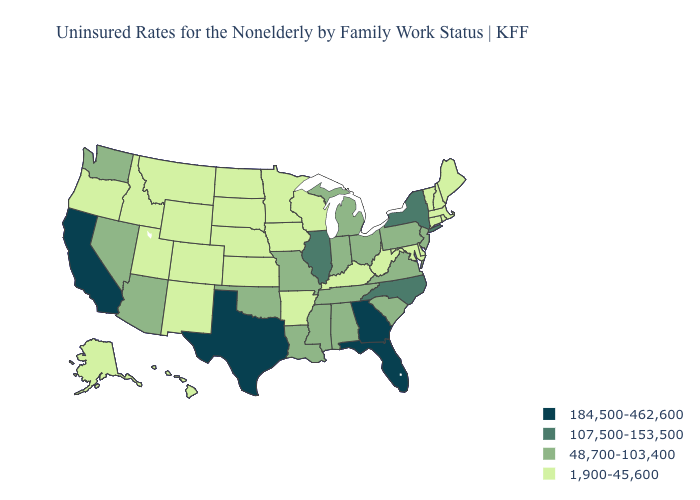Which states hav the highest value in the South?
Short answer required. Florida, Georgia, Texas. What is the value of Connecticut?
Write a very short answer. 1,900-45,600. Does Nevada have the lowest value in the USA?
Be succinct. No. Name the states that have a value in the range 48,700-103,400?
Keep it brief. Alabama, Arizona, Indiana, Louisiana, Michigan, Mississippi, Missouri, Nevada, New Jersey, Ohio, Oklahoma, Pennsylvania, South Carolina, Tennessee, Virginia, Washington. Name the states that have a value in the range 1,900-45,600?
Write a very short answer. Alaska, Arkansas, Colorado, Connecticut, Delaware, Hawaii, Idaho, Iowa, Kansas, Kentucky, Maine, Maryland, Massachusetts, Minnesota, Montana, Nebraska, New Hampshire, New Mexico, North Dakota, Oregon, Rhode Island, South Dakota, Utah, Vermont, West Virginia, Wisconsin, Wyoming. Does New York have a higher value than Arkansas?
Short answer required. Yes. Does Missouri have the same value as Michigan?
Give a very brief answer. Yes. Is the legend a continuous bar?
Short answer required. No. Name the states that have a value in the range 1,900-45,600?
Concise answer only. Alaska, Arkansas, Colorado, Connecticut, Delaware, Hawaii, Idaho, Iowa, Kansas, Kentucky, Maine, Maryland, Massachusetts, Minnesota, Montana, Nebraska, New Hampshire, New Mexico, North Dakota, Oregon, Rhode Island, South Dakota, Utah, Vermont, West Virginia, Wisconsin, Wyoming. Which states hav the highest value in the West?
Answer briefly. California. Does the first symbol in the legend represent the smallest category?
Short answer required. No. Name the states that have a value in the range 48,700-103,400?
Write a very short answer. Alabama, Arizona, Indiana, Louisiana, Michigan, Mississippi, Missouri, Nevada, New Jersey, Ohio, Oklahoma, Pennsylvania, South Carolina, Tennessee, Virginia, Washington. Does Colorado have the lowest value in the USA?
Concise answer only. Yes. What is the value of Utah?
Concise answer only. 1,900-45,600. Name the states that have a value in the range 107,500-153,500?
Be succinct. Illinois, New York, North Carolina. 